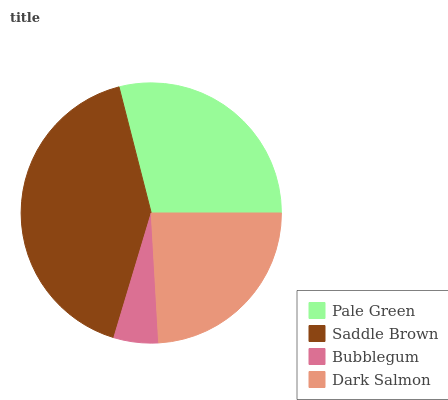Is Bubblegum the minimum?
Answer yes or no. Yes. Is Saddle Brown the maximum?
Answer yes or no. Yes. Is Saddle Brown the minimum?
Answer yes or no. No. Is Bubblegum the maximum?
Answer yes or no. No. Is Saddle Brown greater than Bubblegum?
Answer yes or no. Yes. Is Bubblegum less than Saddle Brown?
Answer yes or no. Yes. Is Bubblegum greater than Saddle Brown?
Answer yes or no. No. Is Saddle Brown less than Bubblegum?
Answer yes or no. No. Is Pale Green the high median?
Answer yes or no. Yes. Is Dark Salmon the low median?
Answer yes or no. Yes. Is Bubblegum the high median?
Answer yes or no. No. Is Saddle Brown the low median?
Answer yes or no. No. 